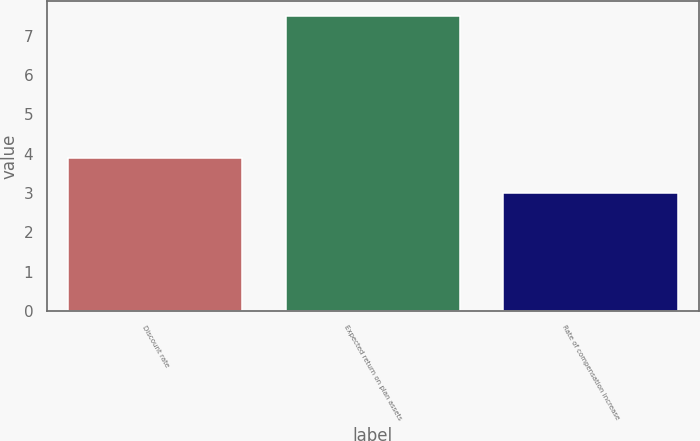Convert chart. <chart><loc_0><loc_0><loc_500><loc_500><bar_chart><fcel>Discount rate<fcel>Expected return on plan assets<fcel>Rate of compensation increase<nl><fcel>3.9<fcel>7.5<fcel>3<nl></chart> 